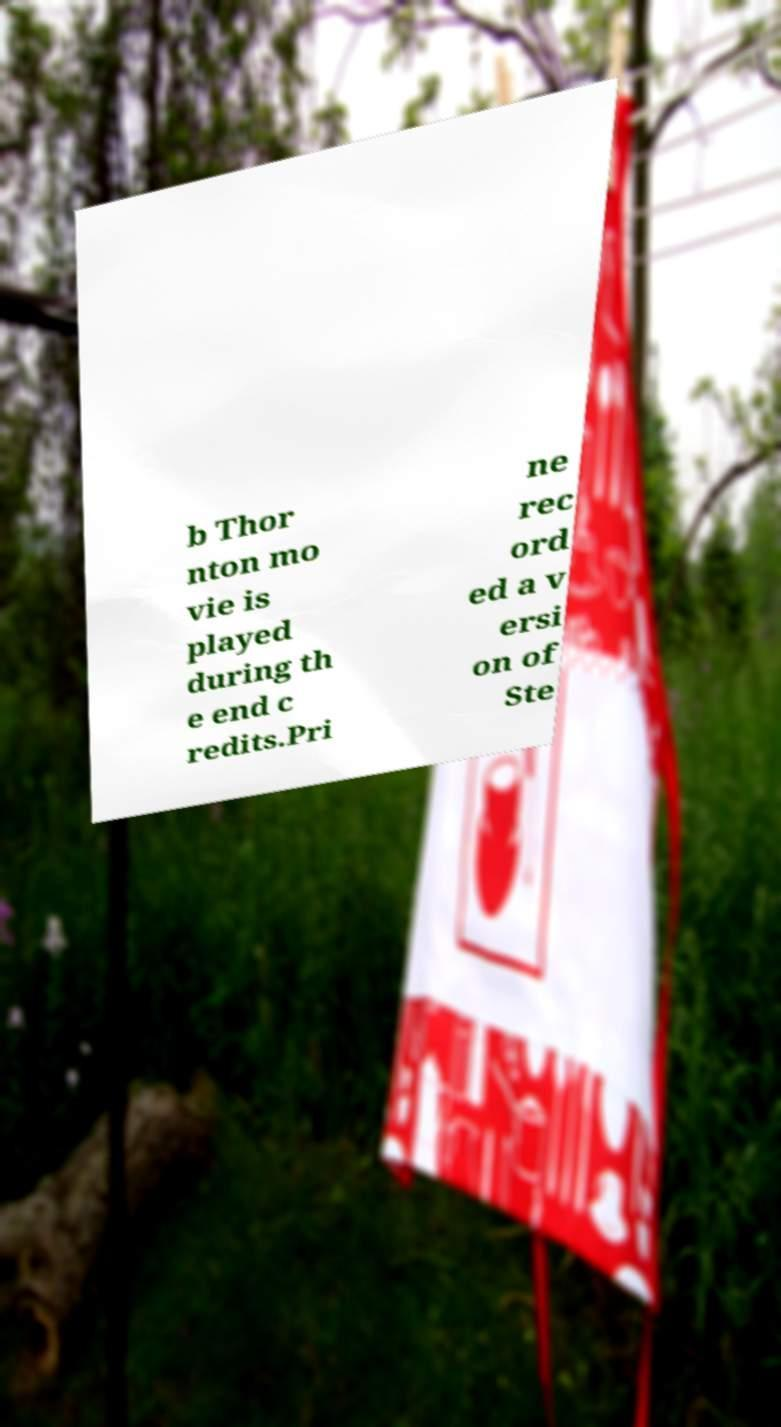What messages or text are displayed in this image? I need them in a readable, typed format. b Thor nton mo vie is played during th e end c redits.Pri ne rec ord ed a v ersi on of Ste 